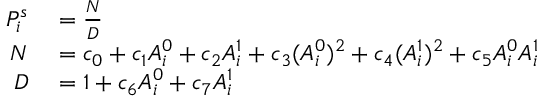<formula> <loc_0><loc_0><loc_500><loc_500>\begin{array} { r l } { P _ { i } ^ { s } } & = \frac { N } { D } } \\ { N } & = c _ { 0 } + c _ { 1 } A _ { i } ^ { 0 } + c _ { 2 } A _ { i } ^ { 1 } + c _ { 3 } ( A _ { i } ^ { 0 } ) ^ { 2 } + c _ { 4 } ( A _ { i } ^ { 1 } ) ^ { 2 } + c _ { 5 } A _ { i } ^ { 0 } A _ { i } ^ { 1 } } \\ { D } & = 1 + c _ { 6 } A _ { i } ^ { 0 } + c _ { 7 } A _ { i } ^ { 1 } } \end{array}</formula> 